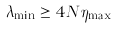<formula> <loc_0><loc_0><loc_500><loc_500>\lambda _ { \min } \geq 4 N \eta _ { \max }</formula> 